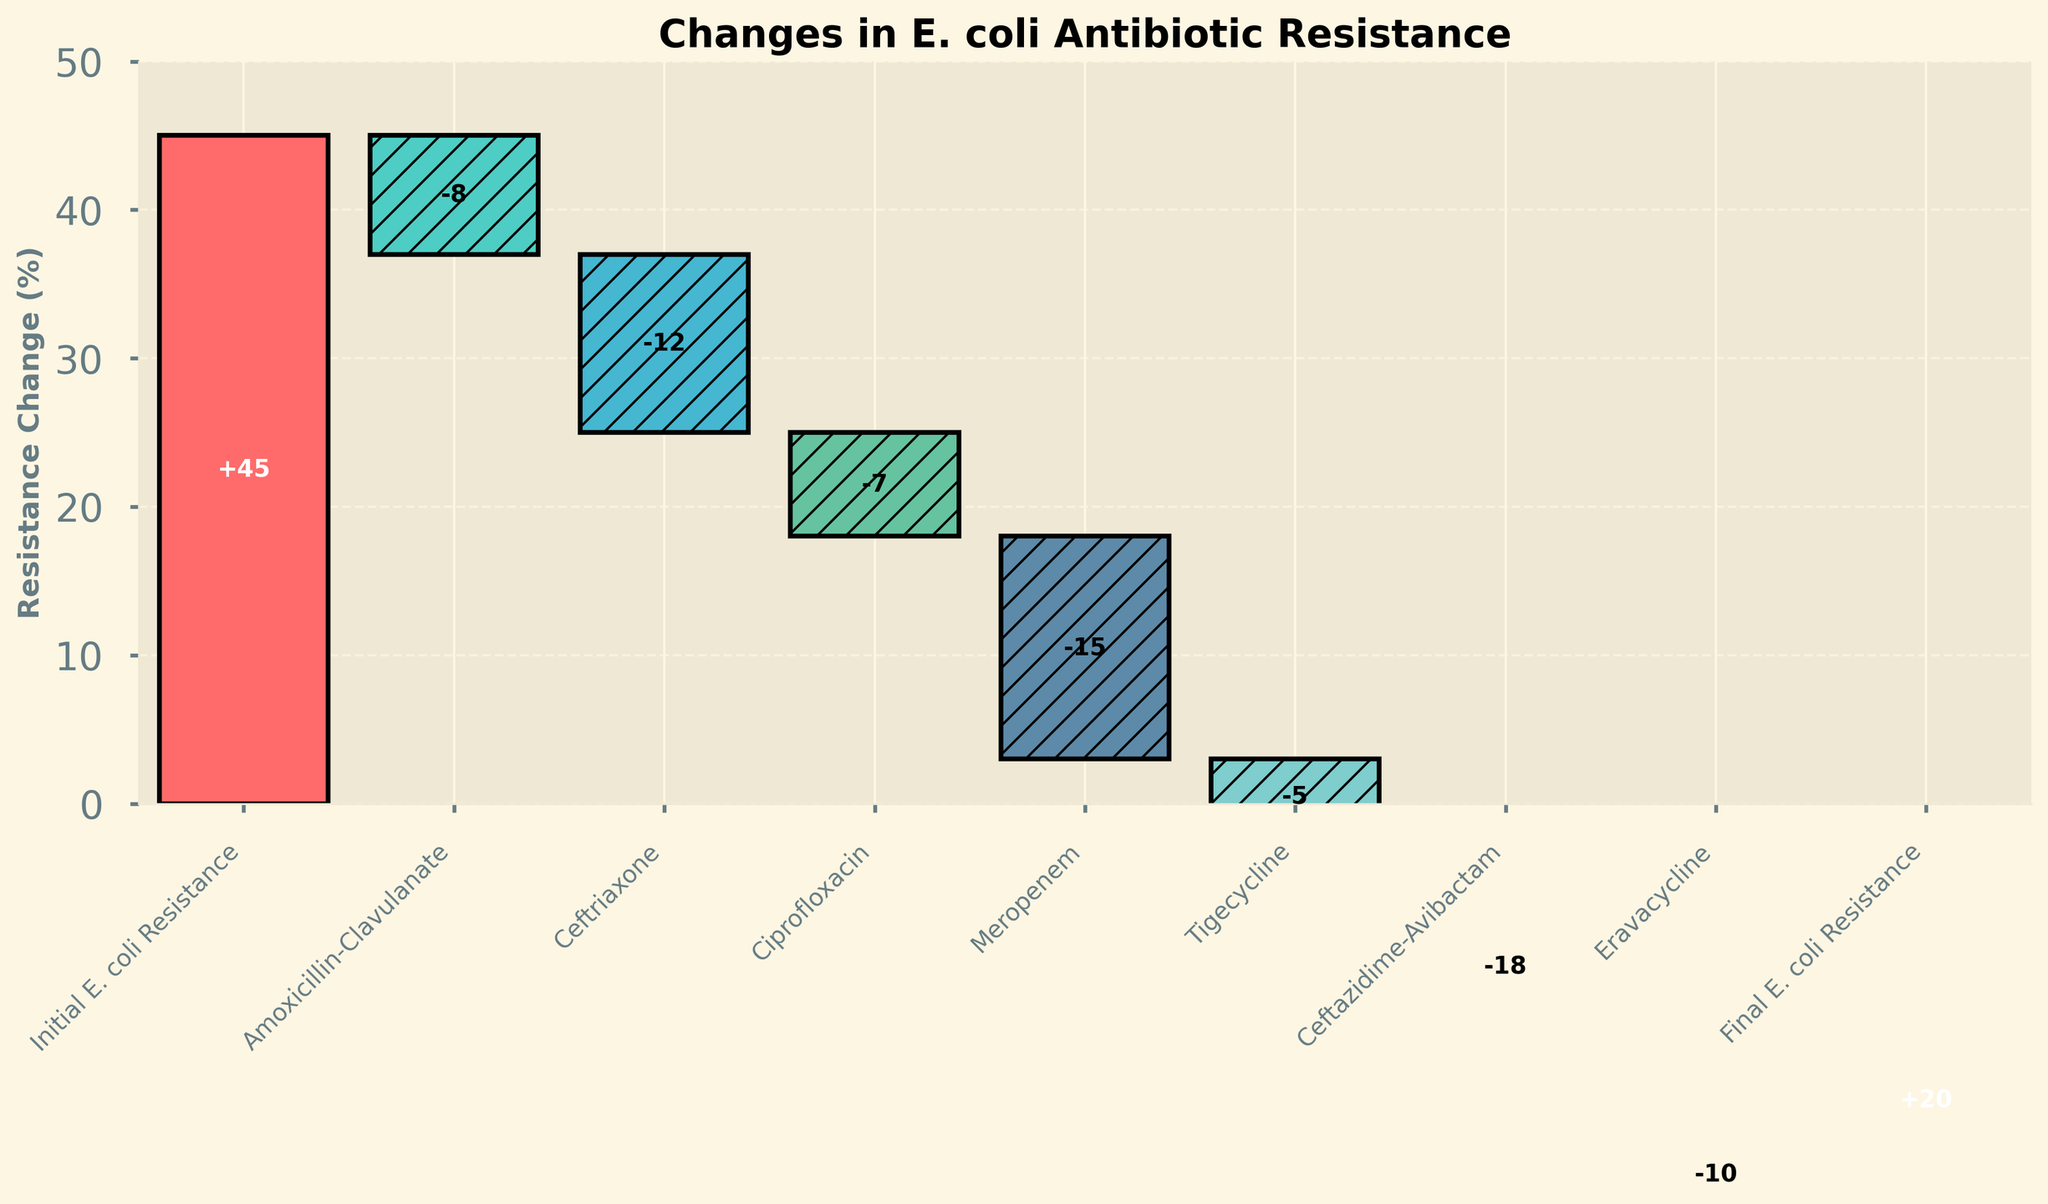How many antibiotics are represented in the chart? Count all the antibiotics listed: Amoxicillin-Clavulanate, Ceftriaxone, Ciprofloxacin, Meropenem, Tigecycline, Ceftazidime-Avibactam, and Eravacycline.
Answer: 7 What is the starting resistance rate of E. coli? Identify the initial value in the 'Resistance_Change' series.
Answer: 45% What is the final resistance rate of E. coli after all antibiotics are considered? Identify the final value in the 'Resistance_Change' series.
Answer: 20% Which antibiotic caused the largest decrease in resistance rate? Identify the antibiotic with the most significant negative change in the 'Resistance_Change' values.
Answer: Ceftazidime-Avibactam Which antibiotics caused more than a 10% decrease in resistance rate? Identify antibiotics from 'Resistance_Change' with values less than -10.
Answer: Ceftriaxone, Meropenem, Ceftazidime-Avibactam, Eravacycline How much did the resistance rate change after the introduction of Ciprofloxacin? Look at the 'Resistance_Change' value associated with Ciprofloxacin.
Answer: -7% What is the cumulative resistance rate change after the introduction of Meropenem? Calculate the initial resistance (45) plus all changes up to and including Meropenem: 45 - 8 - 12 - 7 - 15.
Answer: 3% What is the difference between the resistance rate changes caused by Tigecycline and Eravacycline? Subtract Tigecycline's resistance change (-5) from Eravacycline's resistance change (-10).
Answer: -5% Rank antibiotics from the highest to the lowest reduction in resistance rate. List antibiotics based on the negative 'Resistance_Change' values in descending order: Ceftazidime-Avibactam (-18), Meropenem (-15), Ceftriaxone (-12), Eravacycline (-10), Ciprofloxacin (-7), Amoxicillin-Clavulanate (-8), Tigecycline (-5).
Answer: Ceftazidime-Avibactam, Meropenem, Ceftriaxone, Eravacycline, Ciprofloxacin, Amoxicillin-Clavulanate, Tigecycline How does the resistance reduction of Ciprofloxacin compare to that of Amoxicillin-Clavulanate? Compare the 'Resistance_Change' values for Ciprofloxacin (-7) and Amoxicillin-Clavulanate (-8).
Answer: Ciprofloxacin's reduction is 1% less than Amoxicillin-Clavulanate 